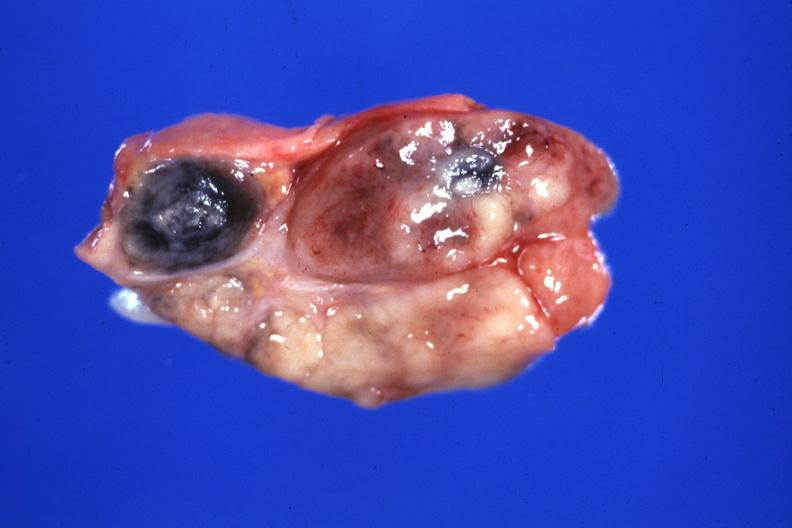what is present?
Answer the question using a single word or phrase. Sarcoidosis 